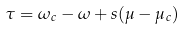<formula> <loc_0><loc_0><loc_500><loc_500>\tau = \omega _ { c } - \omega + s ( \mu - \mu _ { c } )</formula> 